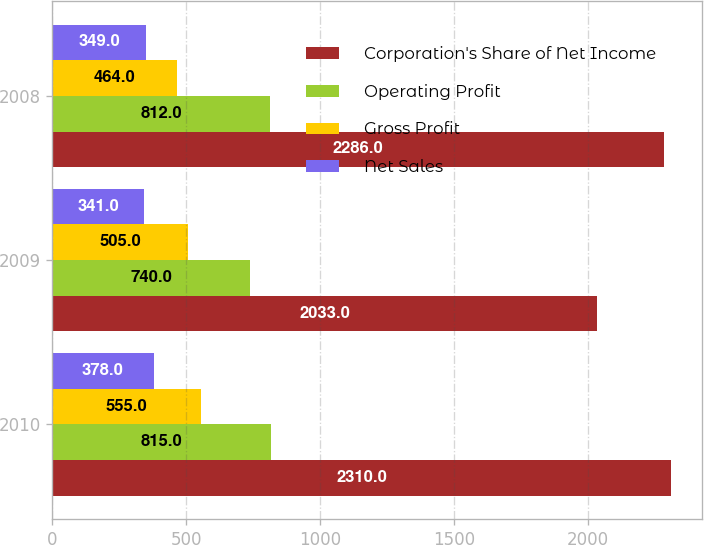Convert chart. <chart><loc_0><loc_0><loc_500><loc_500><stacked_bar_chart><ecel><fcel>2010<fcel>2009<fcel>2008<nl><fcel>Corporation's Share of Net Income<fcel>2310<fcel>2033<fcel>2286<nl><fcel>Operating Profit<fcel>815<fcel>740<fcel>812<nl><fcel>Gross Profit<fcel>555<fcel>505<fcel>464<nl><fcel>Net Sales<fcel>378<fcel>341<fcel>349<nl></chart> 